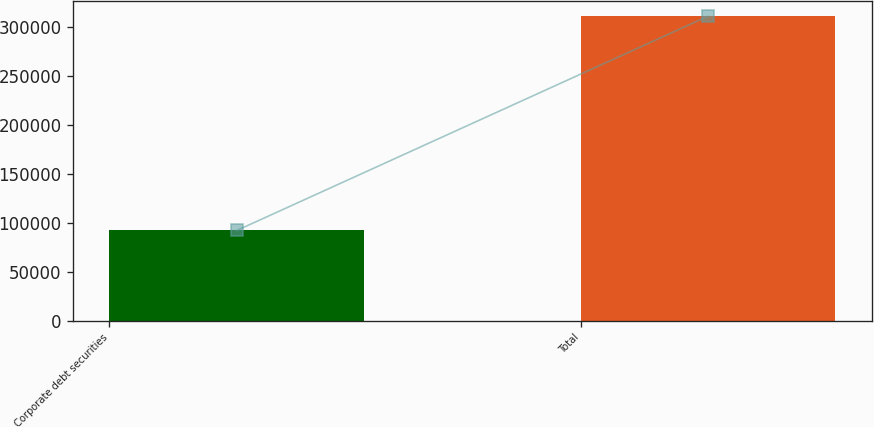<chart> <loc_0><loc_0><loc_500><loc_500><bar_chart><fcel>Corporate debt securities<fcel>Total<nl><fcel>92301<fcel>311265<nl></chart> 